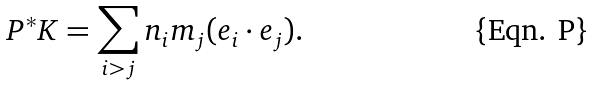Convert formula to latex. <formula><loc_0><loc_0><loc_500><loc_500>P ^ { * } K = \sum _ { i > j } n _ { i } m _ { j } ( e _ { i } \cdot e _ { j } ) .</formula> 